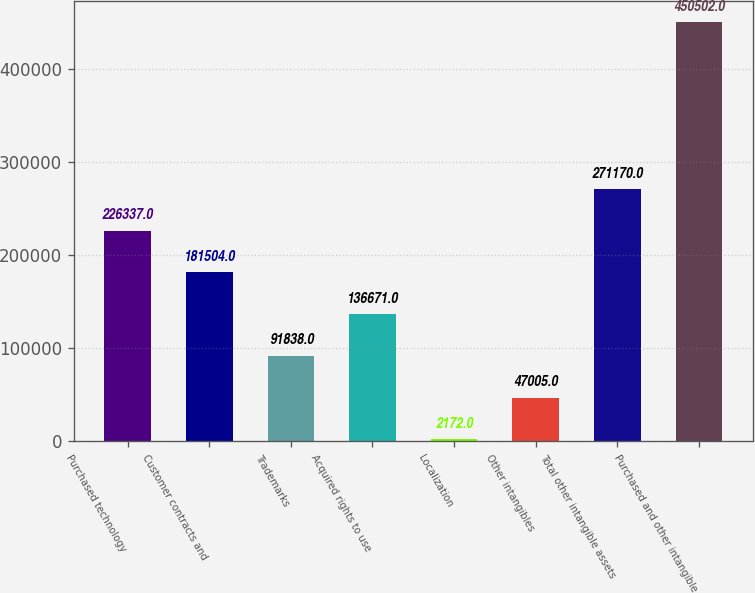Convert chart. <chart><loc_0><loc_0><loc_500><loc_500><bar_chart><fcel>Purchased technology<fcel>Customer contracts and<fcel>Trademarks<fcel>Acquired rights to use<fcel>Localization<fcel>Other intangibles<fcel>Total other intangible assets<fcel>Purchased and other intangible<nl><fcel>226337<fcel>181504<fcel>91838<fcel>136671<fcel>2172<fcel>47005<fcel>271170<fcel>450502<nl></chart> 